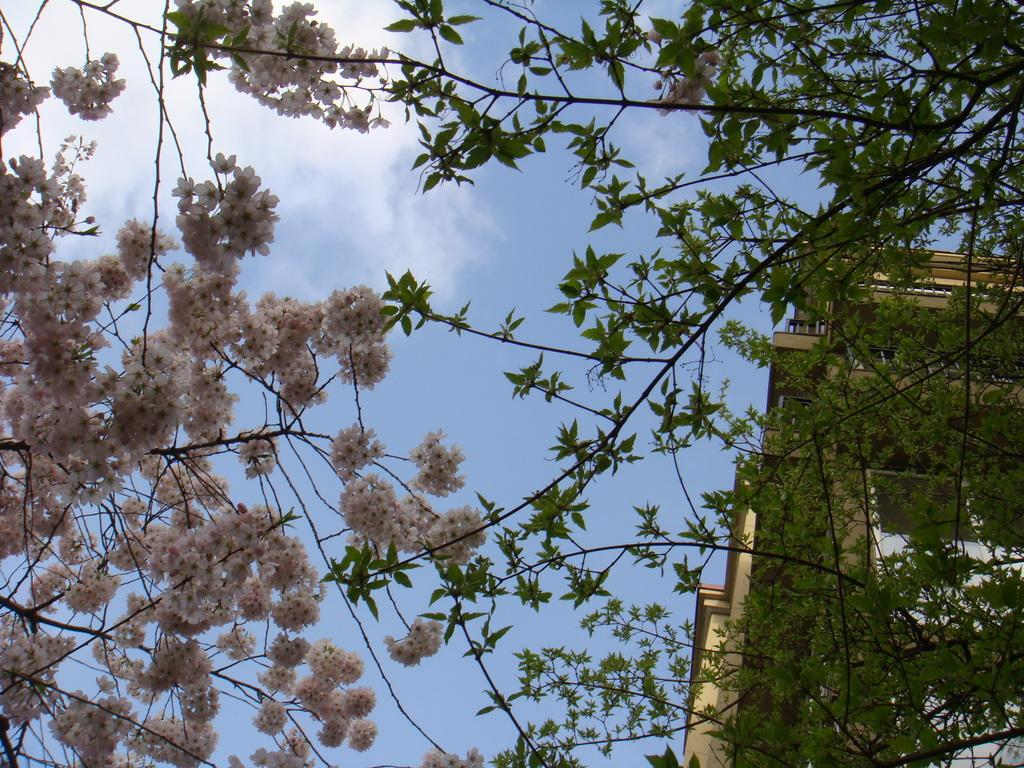What type of plant is featured in the image? There is a flowering tree in the image. What other structure can be seen in the image? There is a building in the image. What color is the building? The building is yellow. What is visible at the top of the image? The sky is visible at the top of the image. Can you tell me how many rings are hanging from the branches of the flowering tree in the image? There are no rings present in the image; it features a flowering tree and a yellow building. Are there any oranges growing on the flowering tree in the image? There are no oranges present in the image; it features a flowering tree and a yellow building. 